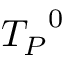<formula> <loc_0><loc_0><loc_500><loc_500>{ T _ { P } } ^ { 0 }</formula> 